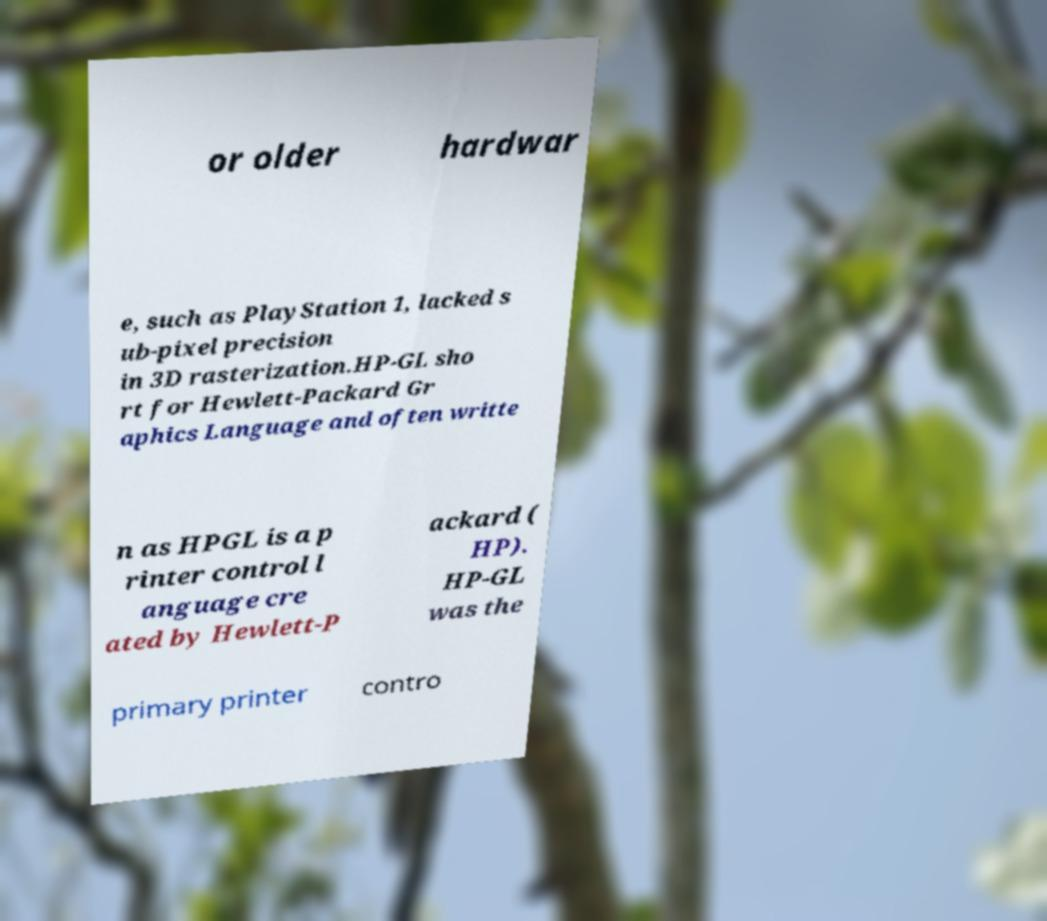Could you assist in decoding the text presented in this image and type it out clearly? or older hardwar e, such as PlayStation 1, lacked s ub-pixel precision in 3D rasterization.HP-GL sho rt for Hewlett-Packard Gr aphics Language and often writte n as HPGL is a p rinter control l anguage cre ated by Hewlett-P ackard ( HP). HP-GL was the primary printer contro 